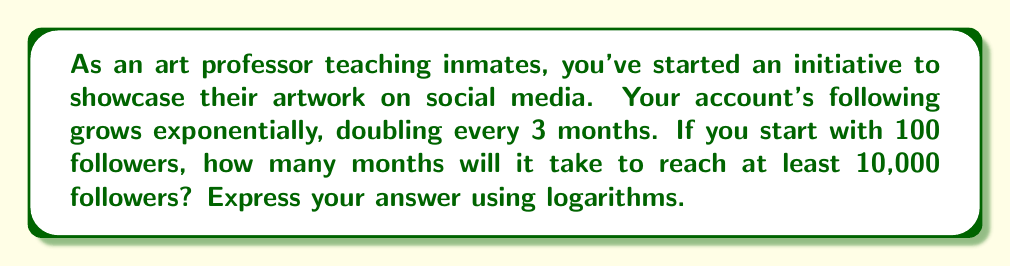Could you help me with this problem? Let's approach this step-by-step:

1) Let $n$ be the number of 3-month periods, and $f(n)$ be the number of followers after $n$ periods.

2) The initial number of followers is 100, and it doubles every period. We can express this as:

   $f(n) = 100 \cdot 2^n$

3) We want to find when this becomes at least 10,000:

   $100 \cdot 2^n \geq 10,000$

4) Divide both sides by 100:

   $2^n \geq 100$

5) Now, we can apply logarithms (base 2) to both sides:

   $\log_2(2^n) \geq \log_2(100)$

6) The left side simplifies due to the logarithm rule $\log_a(a^x) = x$:

   $n \geq \log_2(100)$

7) We can calculate $\log_2(100)$ using the change of base formula:

   $\log_2(100) = \frac{\log(100)}{\log(2)} \approx 6.64386$

8) Since $n$ must be an integer (we can't have a fractional number of 3-month periods), we round up to the next whole number: 7.

9) Therefore, it will take 7 periods of 3 months each, or $7 \cdot 3 = 21$ months.
Answer: $21$ months 